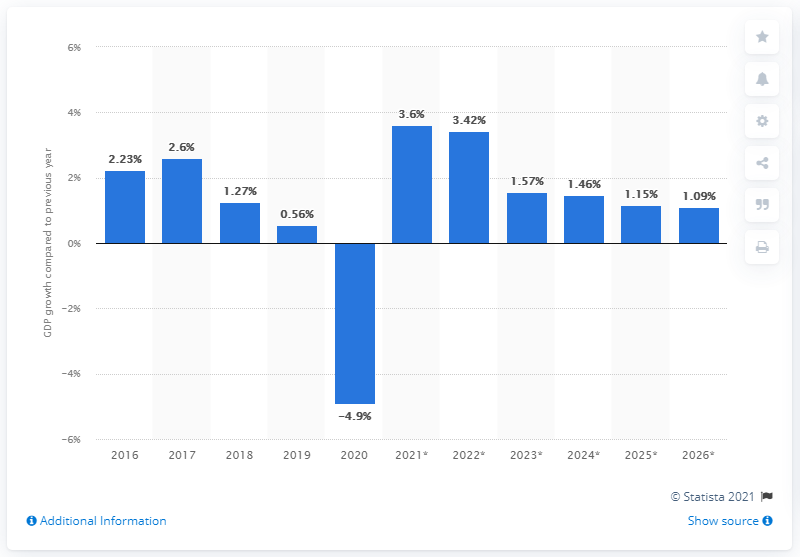List a handful of essential elements in this visual. In the year of 2020, Germany's gross domestic product declined by approximately 4.9 percent. 